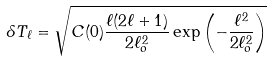Convert formula to latex. <formula><loc_0><loc_0><loc_500><loc_500>\delta T _ { \ell } = \sqrt { C ( 0 ) \frac { \ell ( 2 \ell + 1 ) } { 2 \ell _ { o } ^ { 2 } } \exp \left ( - \frac { \ell ^ { 2 } } { 2 \ell _ { o } ^ { 2 } } \right ) }</formula> 